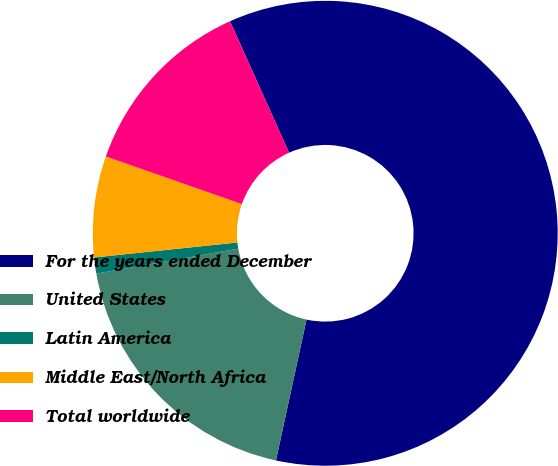Convert chart to OTSL. <chart><loc_0><loc_0><loc_500><loc_500><pie_chart><fcel>For the years ended December<fcel>United States<fcel>Latin America<fcel>Middle East/North Africa<fcel>Total worldwide<nl><fcel>60.12%<fcel>18.82%<fcel>1.12%<fcel>7.02%<fcel>12.92%<nl></chart> 